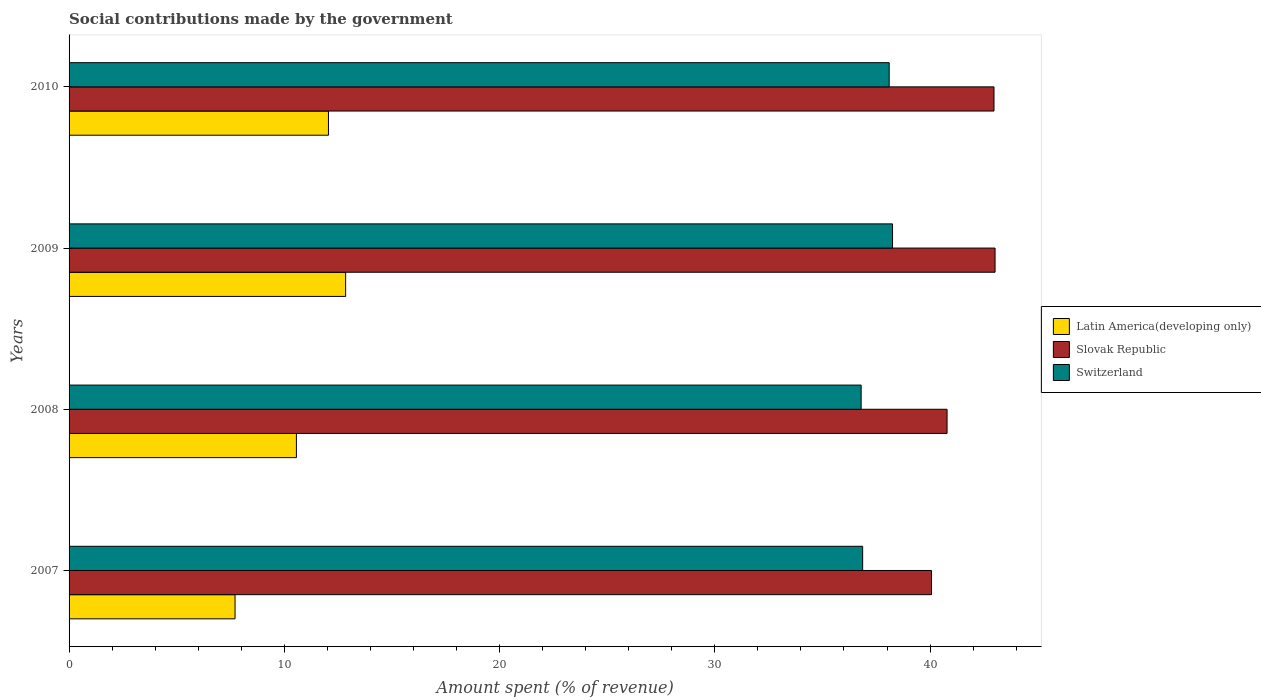How many different coloured bars are there?
Keep it short and to the point. 3. How many groups of bars are there?
Your response must be concise. 4. Are the number of bars per tick equal to the number of legend labels?
Your answer should be very brief. Yes. Are the number of bars on each tick of the Y-axis equal?
Offer a terse response. Yes. What is the amount spent (in %) on social contributions in Slovak Republic in 2010?
Offer a very short reply. 42.97. Across all years, what is the maximum amount spent (in %) on social contributions in Latin America(developing only)?
Make the answer very short. 12.85. Across all years, what is the minimum amount spent (in %) on social contributions in Latin America(developing only)?
Your response must be concise. 7.71. In which year was the amount spent (in %) on social contributions in Latin America(developing only) maximum?
Your answer should be very brief. 2009. In which year was the amount spent (in %) on social contributions in Switzerland minimum?
Your response must be concise. 2008. What is the total amount spent (in %) on social contributions in Switzerland in the graph?
Your answer should be compact. 150.02. What is the difference between the amount spent (in %) on social contributions in Slovak Republic in 2008 and that in 2009?
Your answer should be very brief. -2.23. What is the difference between the amount spent (in %) on social contributions in Switzerland in 2008 and the amount spent (in %) on social contributions in Latin America(developing only) in 2007?
Provide a succinct answer. 29.09. What is the average amount spent (in %) on social contributions in Slovak Republic per year?
Provide a short and direct response. 41.71. In the year 2009, what is the difference between the amount spent (in %) on social contributions in Switzerland and amount spent (in %) on social contributions in Latin America(developing only)?
Ensure brevity in your answer.  25.41. In how many years, is the amount spent (in %) on social contributions in Slovak Republic greater than 10 %?
Provide a succinct answer. 4. What is the ratio of the amount spent (in %) on social contributions in Latin America(developing only) in 2009 to that in 2010?
Provide a succinct answer. 1.07. Is the amount spent (in %) on social contributions in Switzerland in 2009 less than that in 2010?
Keep it short and to the point. No. What is the difference between the highest and the second highest amount spent (in %) on social contributions in Latin America(developing only)?
Your response must be concise. 0.8. What is the difference between the highest and the lowest amount spent (in %) on social contributions in Switzerland?
Your answer should be very brief. 1.46. In how many years, is the amount spent (in %) on social contributions in Slovak Republic greater than the average amount spent (in %) on social contributions in Slovak Republic taken over all years?
Give a very brief answer. 2. Is the sum of the amount spent (in %) on social contributions in Slovak Republic in 2007 and 2009 greater than the maximum amount spent (in %) on social contributions in Switzerland across all years?
Provide a succinct answer. Yes. What does the 2nd bar from the top in 2007 represents?
Provide a short and direct response. Slovak Republic. What does the 2nd bar from the bottom in 2008 represents?
Offer a very short reply. Slovak Republic. How many bars are there?
Give a very brief answer. 12. Are all the bars in the graph horizontal?
Offer a very short reply. Yes. What is the difference between two consecutive major ticks on the X-axis?
Your answer should be compact. 10. Does the graph contain any zero values?
Your answer should be very brief. No. Does the graph contain grids?
Keep it short and to the point. No. Where does the legend appear in the graph?
Provide a succinct answer. Center right. How many legend labels are there?
Provide a succinct answer. 3. How are the legend labels stacked?
Make the answer very short. Vertical. What is the title of the graph?
Make the answer very short. Social contributions made by the government. What is the label or title of the X-axis?
Ensure brevity in your answer.  Amount spent (% of revenue). What is the Amount spent (% of revenue) in Latin America(developing only) in 2007?
Offer a terse response. 7.71. What is the Amount spent (% of revenue) in Slovak Republic in 2007?
Provide a short and direct response. 40.07. What is the Amount spent (% of revenue) in Switzerland in 2007?
Keep it short and to the point. 36.87. What is the Amount spent (% of revenue) in Latin America(developing only) in 2008?
Make the answer very short. 10.56. What is the Amount spent (% of revenue) of Slovak Republic in 2008?
Make the answer very short. 40.79. What is the Amount spent (% of revenue) in Switzerland in 2008?
Make the answer very short. 36.8. What is the Amount spent (% of revenue) of Latin America(developing only) in 2009?
Ensure brevity in your answer.  12.85. What is the Amount spent (% of revenue) of Slovak Republic in 2009?
Make the answer very short. 43.02. What is the Amount spent (% of revenue) of Switzerland in 2009?
Your answer should be compact. 38.26. What is the Amount spent (% of revenue) of Latin America(developing only) in 2010?
Make the answer very short. 12.05. What is the Amount spent (% of revenue) in Slovak Republic in 2010?
Provide a short and direct response. 42.97. What is the Amount spent (% of revenue) of Switzerland in 2010?
Provide a succinct answer. 38.1. Across all years, what is the maximum Amount spent (% of revenue) of Latin America(developing only)?
Provide a short and direct response. 12.85. Across all years, what is the maximum Amount spent (% of revenue) in Slovak Republic?
Offer a very short reply. 43.02. Across all years, what is the maximum Amount spent (% of revenue) of Switzerland?
Offer a very short reply. 38.26. Across all years, what is the minimum Amount spent (% of revenue) in Latin America(developing only)?
Ensure brevity in your answer.  7.71. Across all years, what is the minimum Amount spent (% of revenue) of Slovak Republic?
Provide a short and direct response. 40.07. Across all years, what is the minimum Amount spent (% of revenue) of Switzerland?
Offer a terse response. 36.8. What is the total Amount spent (% of revenue) of Latin America(developing only) in the graph?
Your answer should be compact. 43.17. What is the total Amount spent (% of revenue) in Slovak Republic in the graph?
Offer a very short reply. 166.84. What is the total Amount spent (% of revenue) in Switzerland in the graph?
Keep it short and to the point. 150.02. What is the difference between the Amount spent (% of revenue) of Latin America(developing only) in 2007 and that in 2008?
Make the answer very short. -2.85. What is the difference between the Amount spent (% of revenue) in Slovak Republic in 2007 and that in 2008?
Your answer should be very brief. -0.72. What is the difference between the Amount spent (% of revenue) of Switzerland in 2007 and that in 2008?
Your response must be concise. 0.07. What is the difference between the Amount spent (% of revenue) in Latin America(developing only) in 2007 and that in 2009?
Make the answer very short. -5.14. What is the difference between the Amount spent (% of revenue) of Slovak Republic in 2007 and that in 2009?
Give a very brief answer. -2.95. What is the difference between the Amount spent (% of revenue) in Switzerland in 2007 and that in 2009?
Ensure brevity in your answer.  -1.39. What is the difference between the Amount spent (% of revenue) of Latin America(developing only) in 2007 and that in 2010?
Your response must be concise. -4.34. What is the difference between the Amount spent (% of revenue) in Slovak Republic in 2007 and that in 2010?
Give a very brief answer. -2.9. What is the difference between the Amount spent (% of revenue) in Switzerland in 2007 and that in 2010?
Offer a very short reply. -1.23. What is the difference between the Amount spent (% of revenue) in Latin America(developing only) in 2008 and that in 2009?
Give a very brief answer. -2.29. What is the difference between the Amount spent (% of revenue) of Slovak Republic in 2008 and that in 2009?
Your answer should be very brief. -2.23. What is the difference between the Amount spent (% of revenue) in Switzerland in 2008 and that in 2009?
Your response must be concise. -1.46. What is the difference between the Amount spent (% of revenue) in Latin America(developing only) in 2008 and that in 2010?
Ensure brevity in your answer.  -1.49. What is the difference between the Amount spent (% of revenue) in Slovak Republic in 2008 and that in 2010?
Give a very brief answer. -2.18. What is the difference between the Amount spent (% of revenue) of Switzerland in 2008 and that in 2010?
Give a very brief answer. -1.3. What is the difference between the Amount spent (% of revenue) in Latin America(developing only) in 2009 and that in 2010?
Your answer should be compact. 0.8. What is the difference between the Amount spent (% of revenue) of Slovak Republic in 2009 and that in 2010?
Provide a succinct answer. 0.05. What is the difference between the Amount spent (% of revenue) in Switzerland in 2009 and that in 2010?
Provide a short and direct response. 0.16. What is the difference between the Amount spent (% of revenue) of Latin America(developing only) in 2007 and the Amount spent (% of revenue) of Slovak Republic in 2008?
Provide a short and direct response. -33.08. What is the difference between the Amount spent (% of revenue) in Latin America(developing only) in 2007 and the Amount spent (% of revenue) in Switzerland in 2008?
Provide a succinct answer. -29.09. What is the difference between the Amount spent (% of revenue) in Slovak Republic in 2007 and the Amount spent (% of revenue) in Switzerland in 2008?
Make the answer very short. 3.27. What is the difference between the Amount spent (% of revenue) in Latin America(developing only) in 2007 and the Amount spent (% of revenue) in Slovak Republic in 2009?
Your answer should be compact. -35.31. What is the difference between the Amount spent (% of revenue) of Latin America(developing only) in 2007 and the Amount spent (% of revenue) of Switzerland in 2009?
Offer a terse response. -30.54. What is the difference between the Amount spent (% of revenue) in Slovak Republic in 2007 and the Amount spent (% of revenue) in Switzerland in 2009?
Make the answer very short. 1.81. What is the difference between the Amount spent (% of revenue) of Latin America(developing only) in 2007 and the Amount spent (% of revenue) of Slovak Republic in 2010?
Offer a terse response. -35.26. What is the difference between the Amount spent (% of revenue) of Latin America(developing only) in 2007 and the Amount spent (% of revenue) of Switzerland in 2010?
Ensure brevity in your answer.  -30.39. What is the difference between the Amount spent (% of revenue) of Slovak Republic in 2007 and the Amount spent (% of revenue) of Switzerland in 2010?
Provide a succinct answer. 1.97. What is the difference between the Amount spent (% of revenue) in Latin America(developing only) in 2008 and the Amount spent (% of revenue) in Slovak Republic in 2009?
Provide a succinct answer. -32.46. What is the difference between the Amount spent (% of revenue) of Latin America(developing only) in 2008 and the Amount spent (% of revenue) of Switzerland in 2009?
Ensure brevity in your answer.  -27.69. What is the difference between the Amount spent (% of revenue) of Slovak Republic in 2008 and the Amount spent (% of revenue) of Switzerland in 2009?
Provide a short and direct response. 2.53. What is the difference between the Amount spent (% of revenue) in Latin America(developing only) in 2008 and the Amount spent (% of revenue) in Slovak Republic in 2010?
Ensure brevity in your answer.  -32.41. What is the difference between the Amount spent (% of revenue) in Latin America(developing only) in 2008 and the Amount spent (% of revenue) in Switzerland in 2010?
Give a very brief answer. -27.54. What is the difference between the Amount spent (% of revenue) in Slovak Republic in 2008 and the Amount spent (% of revenue) in Switzerland in 2010?
Provide a short and direct response. 2.69. What is the difference between the Amount spent (% of revenue) in Latin America(developing only) in 2009 and the Amount spent (% of revenue) in Slovak Republic in 2010?
Your answer should be very brief. -30.12. What is the difference between the Amount spent (% of revenue) in Latin America(developing only) in 2009 and the Amount spent (% of revenue) in Switzerland in 2010?
Offer a very short reply. -25.25. What is the difference between the Amount spent (% of revenue) in Slovak Republic in 2009 and the Amount spent (% of revenue) in Switzerland in 2010?
Make the answer very short. 4.92. What is the average Amount spent (% of revenue) of Latin America(developing only) per year?
Your answer should be very brief. 10.79. What is the average Amount spent (% of revenue) in Slovak Republic per year?
Your response must be concise. 41.71. What is the average Amount spent (% of revenue) of Switzerland per year?
Provide a succinct answer. 37.51. In the year 2007, what is the difference between the Amount spent (% of revenue) in Latin America(developing only) and Amount spent (% of revenue) in Slovak Republic?
Keep it short and to the point. -32.36. In the year 2007, what is the difference between the Amount spent (% of revenue) of Latin America(developing only) and Amount spent (% of revenue) of Switzerland?
Your answer should be compact. -29.16. In the year 2007, what is the difference between the Amount spent (% of revenue) of Slovak Republic and Amount spent (% of revenue) of Switzerland?
Provide a succinct answer. 3.2. In the year 2008, what is the difference between the Amount spent (% of revenue) in Latin America(developing only) and Amount spent (% of revenue) in Slovak Republic?
Give a very brief answer. -30.23. In the year 2008, what is the difference between the Amount spent (% of revenue) in Latin America(developing only) and Amount spent (% of revenue) in Switzerland?
Offer a very short reply. -26.24. In the year 2008, what is the difference between the Amount spent (% of revenue) in Slovak Republic and Amount spent (% of revenue) in Switzerland?
Provide a succinct answer. 3.99. In the year 2009, what is the difference between the Amount spent (% of revenue) in Latin America(developing only) and Amount spent (% of revenue) in Slovak Republic?
Give a very brief answer. -30.17. In the year 2009, what is the difference between the Amount spent (% of revenue) of Latin America(developing only) and Amount spent (% of revenue) of Switzerland?
Your answer should be compact. -25.41. In the year 2009, what is the difference between the Amount spent (% of revenue) in Slovak Republic and Amount spent (% of revenue) in Switzerland?
Offer a very short reply. 4.76. In the year 2010, what is the difference between the Amount spent (% of revenue) of Latin America(developing only) and Amount spent (% of revenue) of Slovak Republic?
Your answer should be compact. -30.92. In the year 2010, what is the difference between the Amount spent (% of revenue) of Latin America(developing only) and Amount spent (% of revenue) of Switzerland?
Provide a succinct answer. -26.05. In the year 2010, what is the difference between the Amount spent (% of revenue) of Slovak Republic and Amount spent (% of revenue) of Switzerland?
Offer a terse response. 4.87. What is the ratio of the Amount spent (% of revenue) in Latin America(developing only) in 2007 to that in 2008?
Make the answer very short. 0.73. What is the ratio of the Amount spent (% of revenue) in Slovak Republic in 2007 to that in 2008?
Provide a short and direct response. 0.98. What is the ratio of the Amount spent (% of revenue) in Latin America(developing only) in 2007 to that in 2009?
Your answer should be compact. 0.6. What is the ratio of the Amount spent (% of revenue) of Slovak Republic in 2007 to that in 2009?
Offer a very short reply. 0.93. What is the ratio of the Amount spent (% of revenue) in Switzerland in 2007 to that in 2009?
Offer a terse response. 0.96. What is the ratio of the Amount spent (% of revenue) of Latin America(developing only) in 2007 to that in 2010?
Offer a terse response. 0.64. What is the ratio of the Amount spent (% of revenue) of Slovak Republic in 2007 to that in 2010?
Your answer should be very brief. 0.93. What is the ratio of the Amount spent (% of revenue) of Latin America(developing only) in 2008 to that in 2009?
Give a very brief answer. 0.82. What is the ratio of the Amount spent (% of revenue) of Slovak Republic in 2008 to that in 2009?
Offer a terse response. 0.95. What is the ratio of the Amount spent (% of revenue) in Switzerland in 2008 to that in 2009?
Keep it short and to the point. 0.96. What is the ratio of the Amount spent (% of revenue) in Latin America(developing only) in 2008 to that in 2010?
Offer a terse response. 0.88. What is the ratio of the Amount spent (% of revenue) in Slovak Republic in 2008 to that in 2010?
Ensure brevity in your answer.  0.95. What is the ratio of the Amount spent (% of revenue) in Switzerland in 2008 to that in 2010?
Ensure brevity in your answer.  0.97. What is the ratio of the Amount spent (% of revenue) of Latin America(developing only) in 2009 to that in 2010?
Provide a short and direct response. 1.07. What is the ratio of the Amount spent (% of revenue) in Slovak Republic in 2009 to that in 2010?
Provide a succinct answer. 1. What is the difference between the highest and the second highest Amount spent (% of revenue) of Latin America(developing only)?
Your response must be concise. 0.8. What is the difference between the highest and the second highest Amount spent (% of revenue) of Slovak Republic?
Keep it short and to the point. 0.05. What is the difference between the highest and the second highest Amount spent (% of revenue) of Switzerland?
Your response must be concise. 0.16. What is the difference between the highest and the lowest Amount spent (% of revenue) of Latin America(developing only)?
Provide a short and direct response. 5.14. What is the difference between the highest and the lowest Amount spent (% of revenue) of Slovak Republic?
Offer a terse response. 2.95. What is the difference between the highest and the lowest Amount spent (% of revenue) of Switzerland?
Make the answer very short. 1.46. 